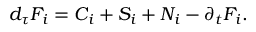Convert formula to latex. <formula><loc_0><loc_0><loc_500><loc_500>{ d } _ { \tau } F _ { i } = C _ { i } + S _ { i } + N _ { i } - \partial _ { t } F _ { i } .</formula> 